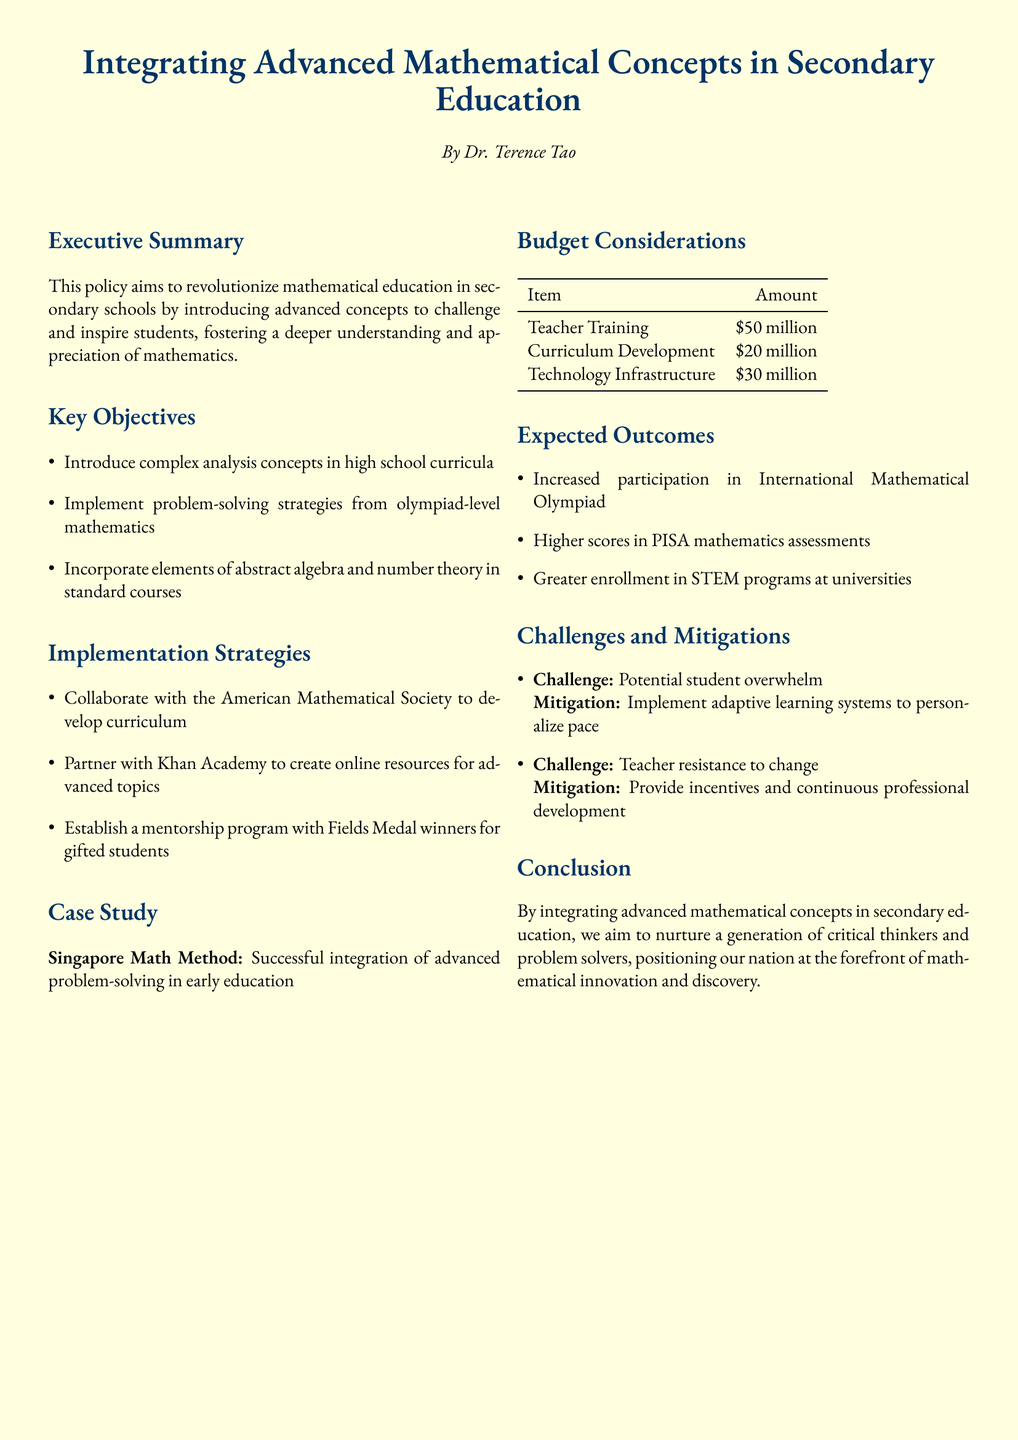What is the main aim of the policy? The main aim of the policy is to revolutionize mathematical education in secondary schools.
Answer: Revolutionize mathematical education Who is the author of the document? The author of the document is Dr. Terence Tao.
Answer: Dr. Terence Tao What are the budget considerations for teacher training? The budget consideration for teacher training is stated in the document's budget table.
Answer: 50 million What advanced mathematical concepts are to be introduced? The document lists the advanced concepts to be introduced in the key objectives section.
Answer: Complex analysis What partnership is suggested for online resources? The partnership suggested in the implementation strategies section is with Khan Academy.
Answer: Khan Academy What is a challenge mentioned in the document? There are several challenges mentioned, but one specific challenge is detailed in the challenges section.
Answer: Potential student overwhelm What is one expected outcome of the policy? The expected outcomes are listed in the document, and one specific outcome is stated clearly.
Answer: Increased participation in International Mathematical Olympiad How much is allocated for technology infrastructure? The allocation for technology infrastructure is stated in the budget consideration table.
Answer: 30 million 